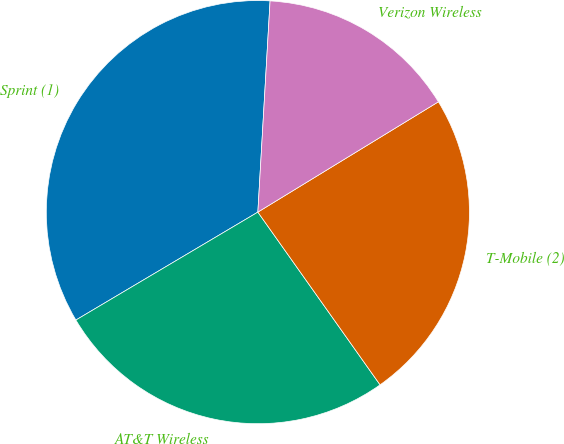Convert chart to OTSL. <chart><loc_0><loc_0><loc_500><loc_500><pie_chart><fcel>Sprint (1)<fcel>AT&T Wireless<fcel>T-Mobile (2)<fcel>Verizon Wireless<nl><fcel>34.44%<fcel>26.28%<fcel>23.93%<fcel>15.35%<nl></chart> 